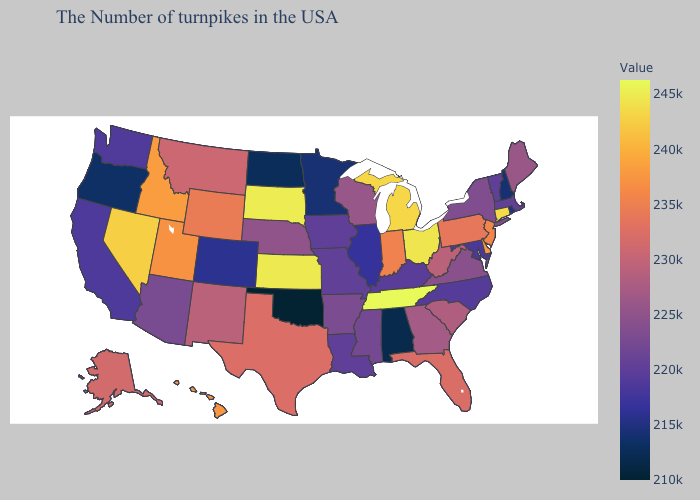Among the states that border Louisiana , which have the lowest value?
Short answer required. Mississippi. Does Indiana have a higher value than Ohio?
Be succinct. No. Does New Mexico have a lower value than Utah?
Quick response, please. Yes. Which states have the lowest value in the South?
Quick response, please. Oklahoma. 